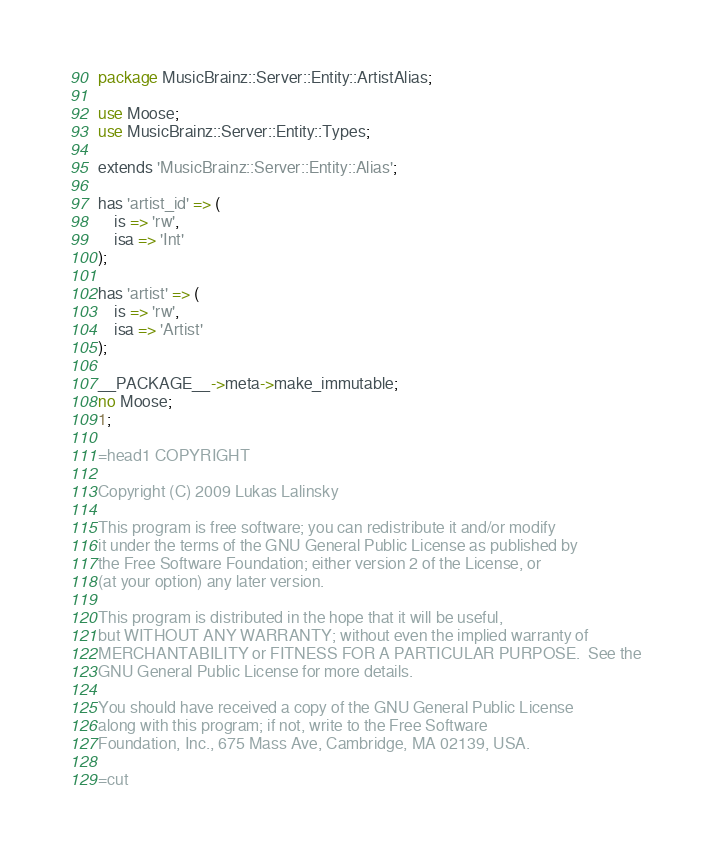<code> <loc_0><loc_0><loc_500><loc_500><_Perl_>package MusicBrainz::Server::Entity::ArtistAlias;

use Moose;
use MusicBrainz::Server::Entity::Types;

extends 'MusicBrainz::Server::Entity::Alias';

has 'artist_id' => (
    is => 'rw',
    isa => 'Int'
);

has 'artist' => (
    is => 'rw',
    isa => 'Artist'
);

__PACKAGE__->meta->make_immutable;
no Moose;
1;

=head1 COPYRIGHT

Copyright (C) 2009 Lukas Lalinsky

This program is free software; you can redistribute it and/or modify
it under the terms of the GNU General Public License as published by
the Free Software Foundation; either version 2 of the License, or
(at your option) any later version.

This program is distributed in the hope that it will be useful,
but WITHOUT ANY WARRANTY; without even the implied warranty of
MERCHANTABILITY or FITNESS FOR A PARTICULAR PURPOSE.  See the
GNU General Public License for more details.

You should have received a copy of the GNU General Public License
along with this program; if not, write to the Free Software
Foundation, Inc., 675 Mass Ave, Cambridge, MA 02139, USA.

=cut
</code> 